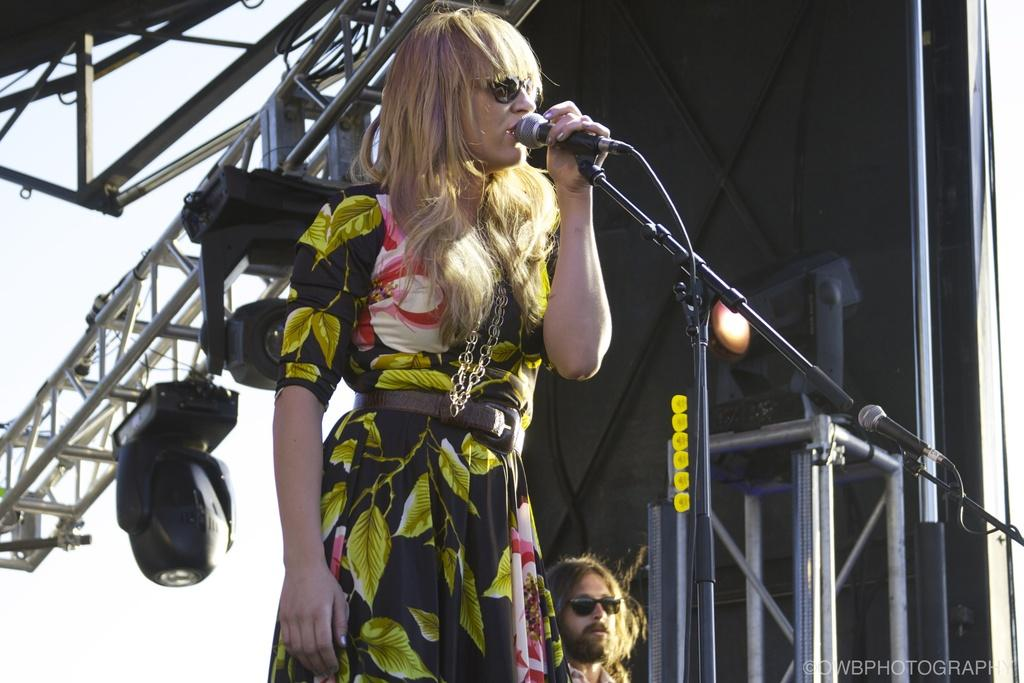What is the woman doing on the stage? The woman is standing on the stage and singing. What is the woman holding while singing? The woman is holding a microphone. What is the purpose of the microphone stand in front of the woman? The microphone stand is likely there to hold the microphone when the woman is not using it. Can you describe the man behind the woman? The man is wearing spectacles. What type of fuel is being used by the woman to sing in the image? There is no reference to fuel in the image, as singing does not require fuel. 